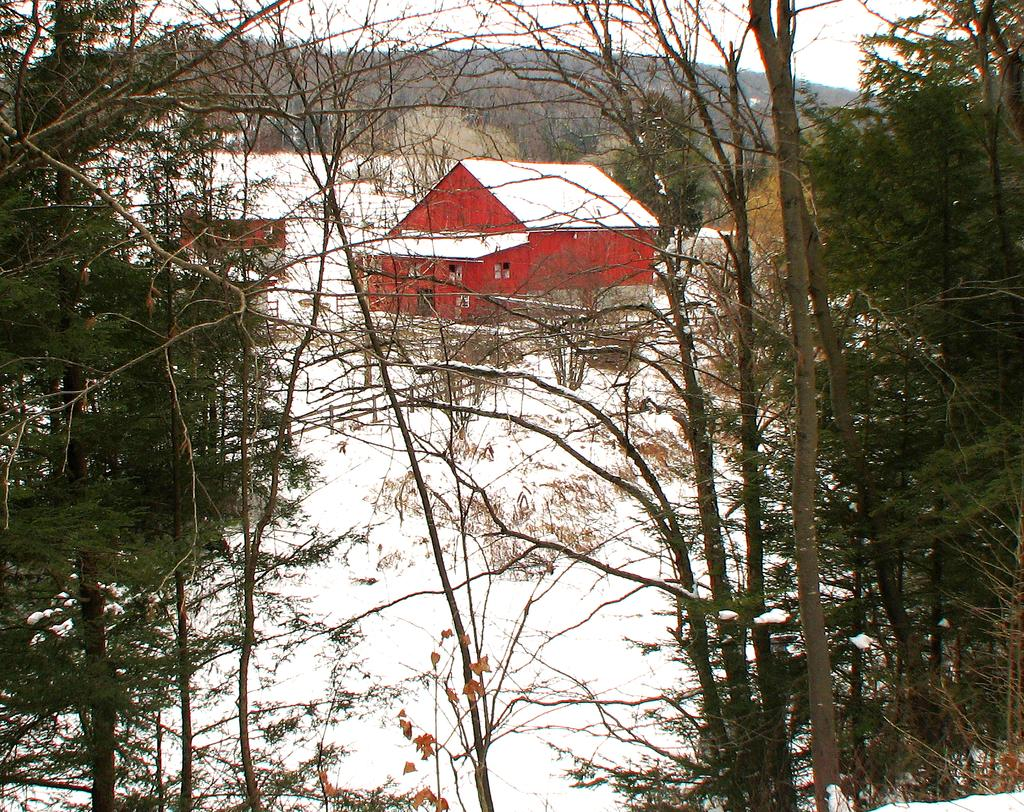What type of vegetation is present in the image? There are trees in the image. What is the weather like in the image? There is snow in the image, indicating a cold and likely wintery scene. What can be seen in the background of the image? In the background of the image, there are trees, a house, snow, and other objects. What part of the natural environment is visible in the image? The sky is visible in the background of the image. What type of stone is being requested by the person in the image? There is no person present in the image, and therefore no request for a stone can be observed. What type of rock is visible in the image? There is no rock visible in the image; the main subjects are trees, snow, and a house. 